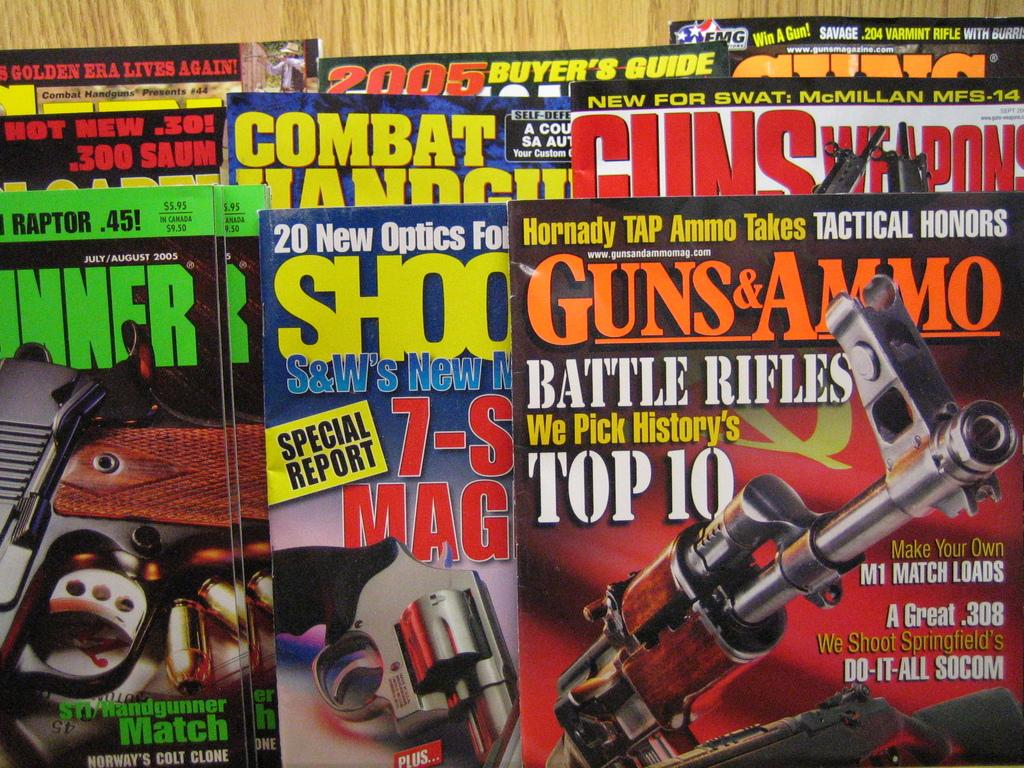<image>
Give a short and clear explanation of the subsequent image. A lot of different magazines are laid out on a table about guns including a magazine titled Guns & Ammo. 